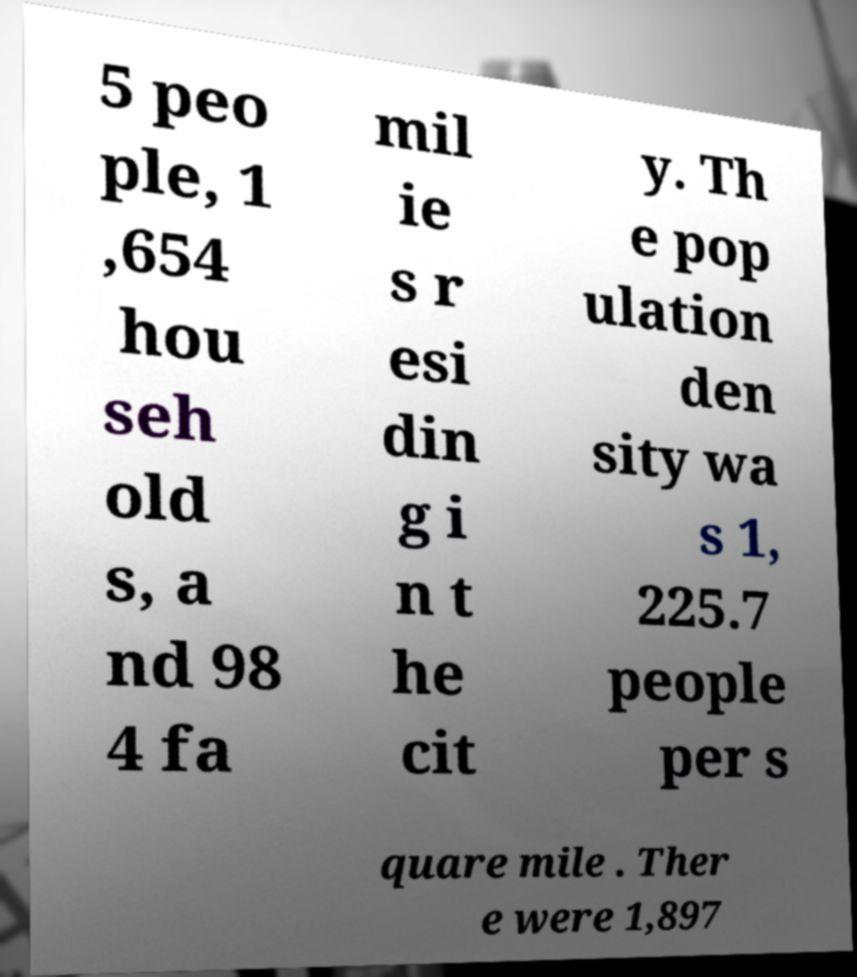There's text embedded in this image that I need extracted. Can you transcribe it verbatim? 5 peo ple, 1 ,654 hou seh old s, a nd 98 4 fa mil ie s r esi din g i n t he cit y. Th e pop ulation den sity wa s 1, 225.7 people per s quare mile . Ther e were 1,897 